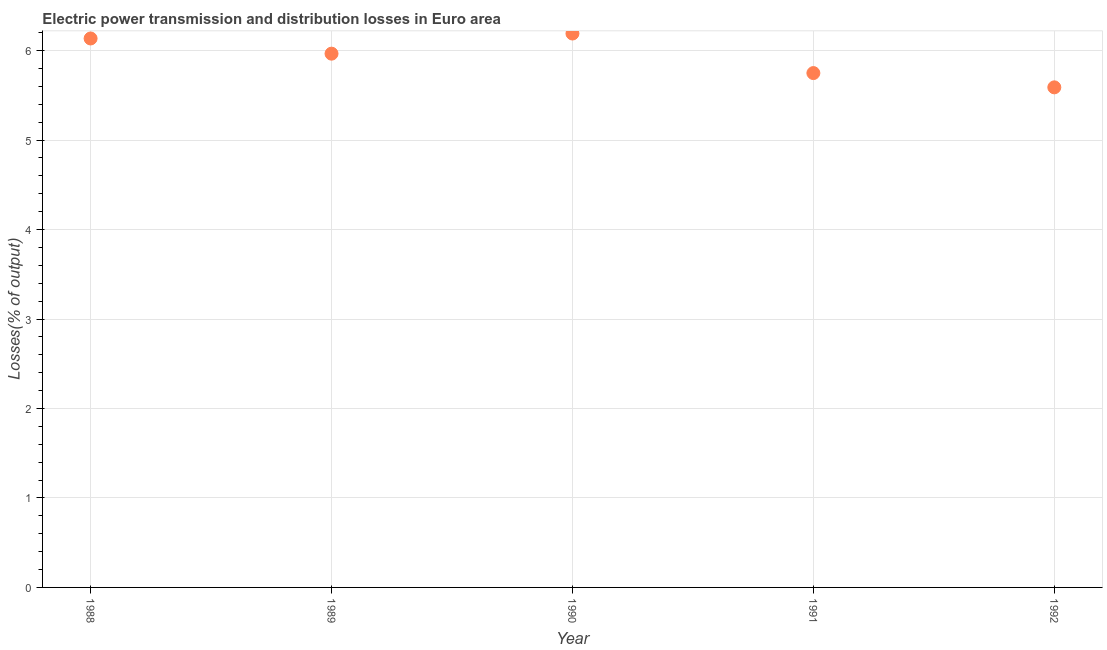What is the electric power transmission and distribution losses in 1992?
Provide a succinct answer. 5.59. Across all years, what is the maximum electric power transmission and distribution losses?
Make the answer very short. 6.19. Across all years, what is the minimum electric power transmission and distribution losses?
Offer a very short reply. 5.59. In which year was the electric power transmission and distribution losses maximum?
Offer a terse response. 1990. What is the sum of the electric power transmission and distribution losses?
Ensure brevity in your answer.  29.63. What is the difference between the electric power transmission and distribution losses in 1989 and 1991?
Keep it short and to the point. 0.22. What is the average electric power transmission and distribution losses per year?
Ensure brevity in your answer.  5.93. What is the median electric power transmission and distribution losses?
Offer a terse response. 5.97. In how many years, is the electric power transmission and distribution losses greater than 0.6000000000000001 %?
Give a very brief answer. 5. What is the ratio of the electric power transmission and distribution losses in 1991 to that in 1992?
Give a very brief answer. 1.03. What is the difference between the highest and the second highest electric power transmission and distribution losses?
Your answer should be very brief. 0.06. Is the sum of the electric power transmission and distribution losses in 1990 and 1992 greater than the maximum electric power transmission and distribution losses across all years?
Give a very brief answer. Yes. What is the difference between the highest and the lowest electric power transmission and distribution losses?
Provide a short and direct response. 0.6. How many dotlines are there?
Your answer should be very brief. 1. How many years are there in the graph?
Your answer should be compact. 5. What is the difference between two consecutive major ticks on the Y-axis?
Your answer should be very brief. 1. Are the values on the major ticks of Y-axis written in scientific E-notation?
Your response must be concise. No. What is the title of the graph?
Offer a very short reply. Electric power transmission and distribution losses in Euro area. What is the label or title of the Y-axis?
Provide a succinct answer. Losses(% of output). What is the Losses(% of output) in 1988?
Provide a succinct answer. 6.14. What is the Losses(% of output) in 1989?
Give a very brief answer. 5.97. What is the Losses(% of output) in 1990?
Keep it short and to the point. 6.19. What is the Losses(% of output) in 1991?
Your answer should be very brief. 5.75. What is the Losses(% of output) in 1992?
Ensure brevity in your answer.  5.59. What is the difference between the Losses(% of output) in 1988 and 1989?
Offer a very short reply. 0.17. What is the difference between the Losses(% of output) in 1988 and 1990?
Give a very brief answer. -0.06. What is the difference between the Losses(% of output) in 1988 and 1991?
Your answer should be very brief. 0.39. What is the difference between the Losses(% of output) in 1988 and 1992?
Keep it short and to the point. 0.55. What is the difference between the Losses(% of output) in 1989 and 1990?
Give a very brief answer. -0.23. What is the difference between the Losses(% of output) in 1989 and 1991?
Keep it short and to the point. 0.22. What is the difference between the Losses(% of output) in 1989 and 1992?
Provide a short and direct response. 0.38. What is the difference between the Losses(% of output) in 1990 and 1991?
Provide a short and direct response. 0.44. What is the difference between the Losses(% of output) in 1990 and 1992?
Offer a very short reply. 0.6. What is the difference between the Losses(% of output) in 1991 and 1992?
Make the answer very short. 0.16. What is the ratio of the Losses(% of output) in 1988 to that in 1989?
Offer a very short reply. 1.03. What is the ratio of the Losses(% of output) in 1988 to that in 1990?
Your answer should be compact. 0.99. What is the ratio of the Losses(% of output) in 1988 to that in 1991?
Your answer should be compact. 1.07. What is the ratio of the Losses(% of output) in 1988 to that in 1992?
Give a very brief answer. 1.1. What is the ratio of the Losses(% of output) in 1989 to that in 1990?
Your response must be concise. 0.96. What is the ratio of the Losses(% of output) in 1989 to that in 1991?
Provide a short and direct response. 1.04. What is the ratio of the Losses(% of output) in 1989 to that in 1992?
Make the answer very short. 1.07. What is the ratio of the Losses(% of output) in 1990 to that in 1991?
Provide a succinct answer. 1.08. What is the ratio of the Losses(% of output) in 1990 to that in 1992?
Provide a succinct answer. 1.11. What is the ratio of the Losses(% of output) in 1991 to that in 1992?
Provide a succinct answer. 1.03. 